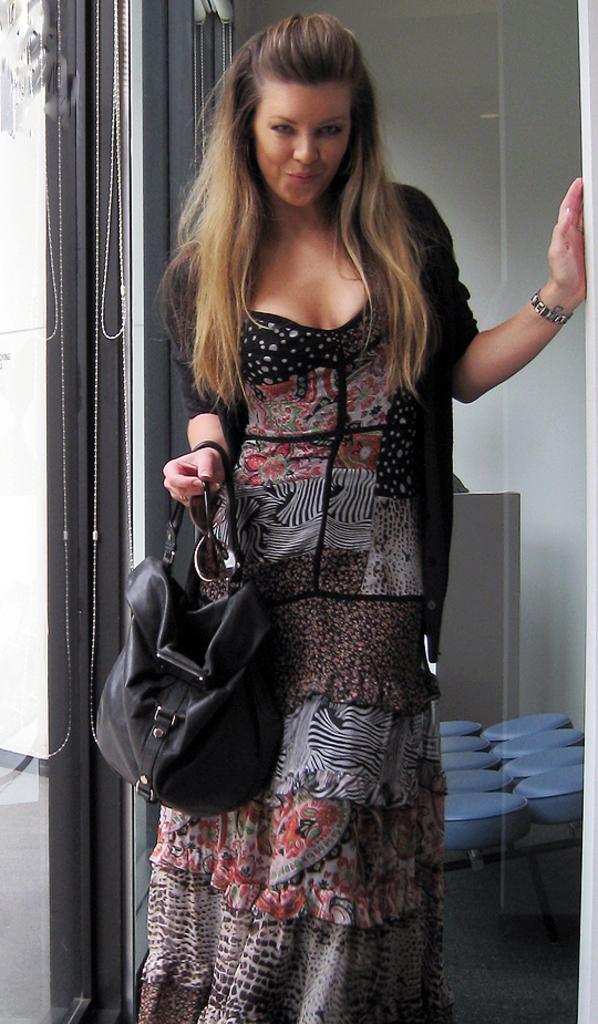How would you summarize this image in a sentence or two? Here we have a lady who is standing and posing for picture, she holds handbag of black color and she also holds spectacles or goggles and here we have glass window. At the background we have wall and here we have seats. 